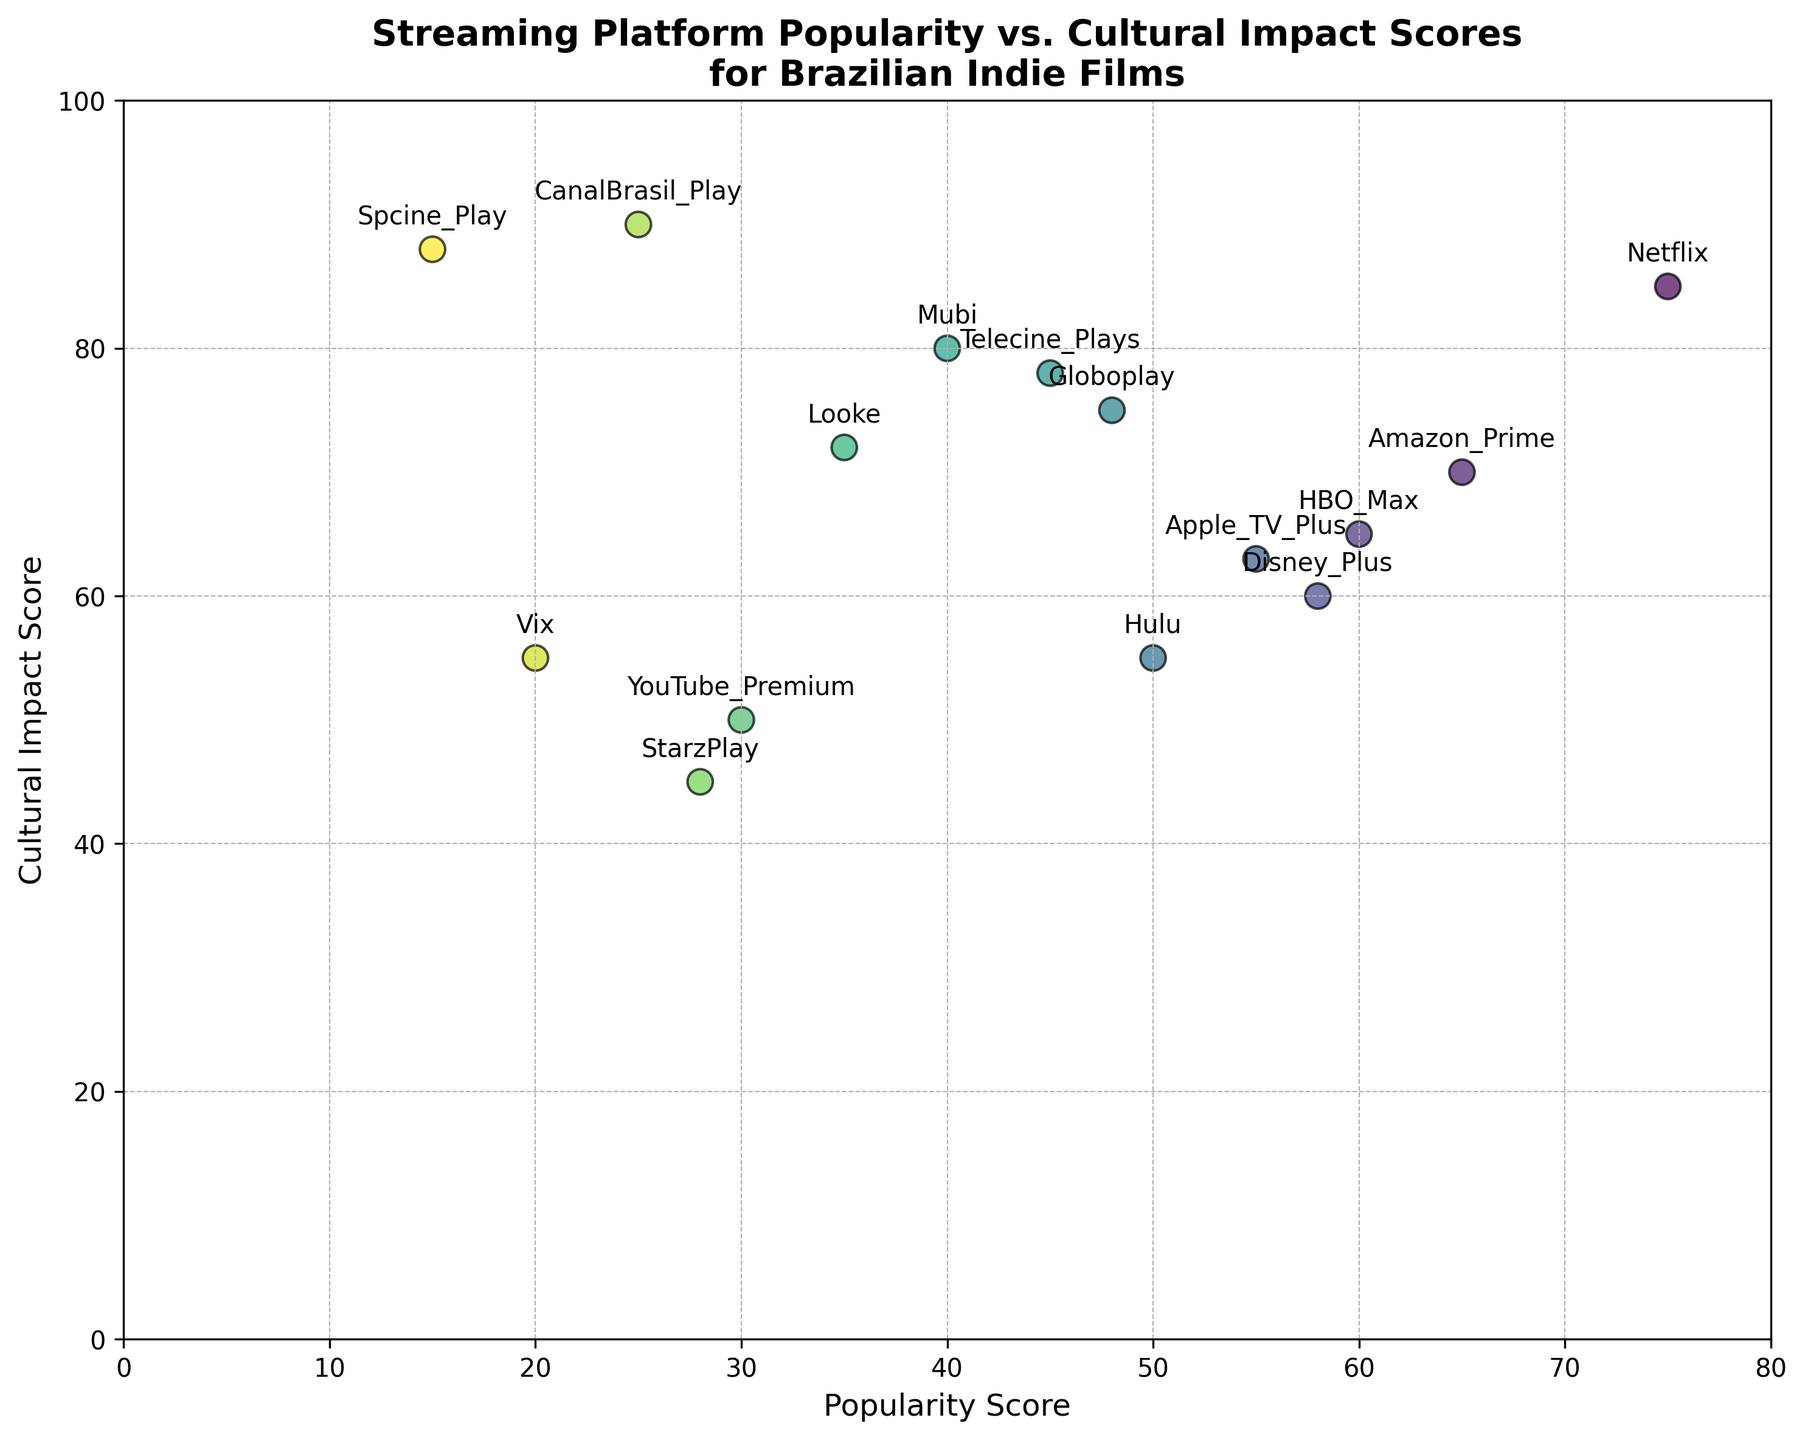Which streaming platform has the highest Cultural Impact Score? Look at the Cultural Impact Score axis and identify the platform at the topmost position. CanalBrasil_Play is at the top of the axis with a score of 90.
Answer: CanalBrasil_Play Which streaming platform has the lowest Popularity Score? Examine the Popularity Score axis and find the platform at the leftmost position. Spcine_Play is at the leftmost end with a score of 15.
Answer: Spcine_Play Which streaming platform with a Popularity Score below 50 has the highest Cultural Impact Score? Focus on the platforms with a Popularity Score less than 50. Among them, find the one with the highest Cultural Impact Score. Spcine_Play, with a Popularity Score of 15, has the highest Cultural Impact Score of 88 in this range.
Answer: Spcine_Play What is the average Popularity Score of the platforms with a Cultural Impact Score above 80? Identify the platforms with Cultural Impact Scores above 80: Netflix, Mubi, CanalBrasil_Play, and Spcine_Play. Calculate their average Popularity Score. \( \frac{75 + 40 + 25 + 15}{4} = 38.75 \)
Answer: 38.75 Is there any streaming platform with both Popularity Score and Cultural Impact Score above 70? Check each platform's scores and see if any meet the criteria. None of the platforms have both scores above 70.
Answer: No How does Globoplay's Cultural Impact Score compare to Netflix's? Compare the Cultural Impact Scores of Globoplay (75) and Netflix (85). Globoplay's score is lower.
Answer: Lower Which platforms have similar Cultural Impact Scores? Identify platforms with close Cultural Impact Scores. Amazon_Prime (70) and Apple_TV_Plus (63) have close scores, as do HBO_Max (65) and Vix (55).
Answer: Amazon_Prime and Apple_TV_Plus; HBO_Max and Vix What is the median Popularity Score of all platforms? Sort the Popularity Scores and determine the median. Ordered scores: 15, 20, 25, 28, 30, 35, 40, 45, 48, 50, 55, 58, 60, 65, 75. The median (middle value) is 45.
Answer: 45 Is there a platform with a higher Cultural Impact Score but lower Popularity Score than Amazon_Prime? Compare Cultural Impact Scores and Popularity Scores with those of Amazon_Prime (scores: 70, 65). Telecine_Plays (78, 45), Mubi (80, 40), Globoplay (75, 48), CanalBrasil_Play (90, 25), and Spcine_Play (88, 15) meet the criteria.
Answer: Telecine_Plays, Mubi, Globoplay, CanalBrasil_Play, Spcine_Play 